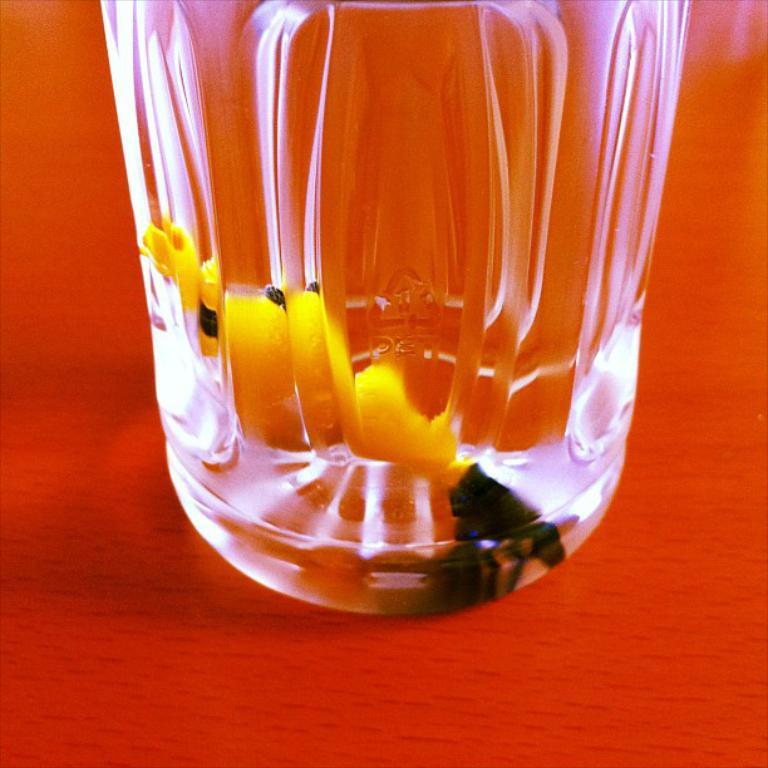What is the main object in the image? There is a glass-like object in the image. What can be found inside the glass-like object? There is something inside the glass-like object. Can you see any wilderness or corn in the image? No, there is no wilderness or corn present in the image. 